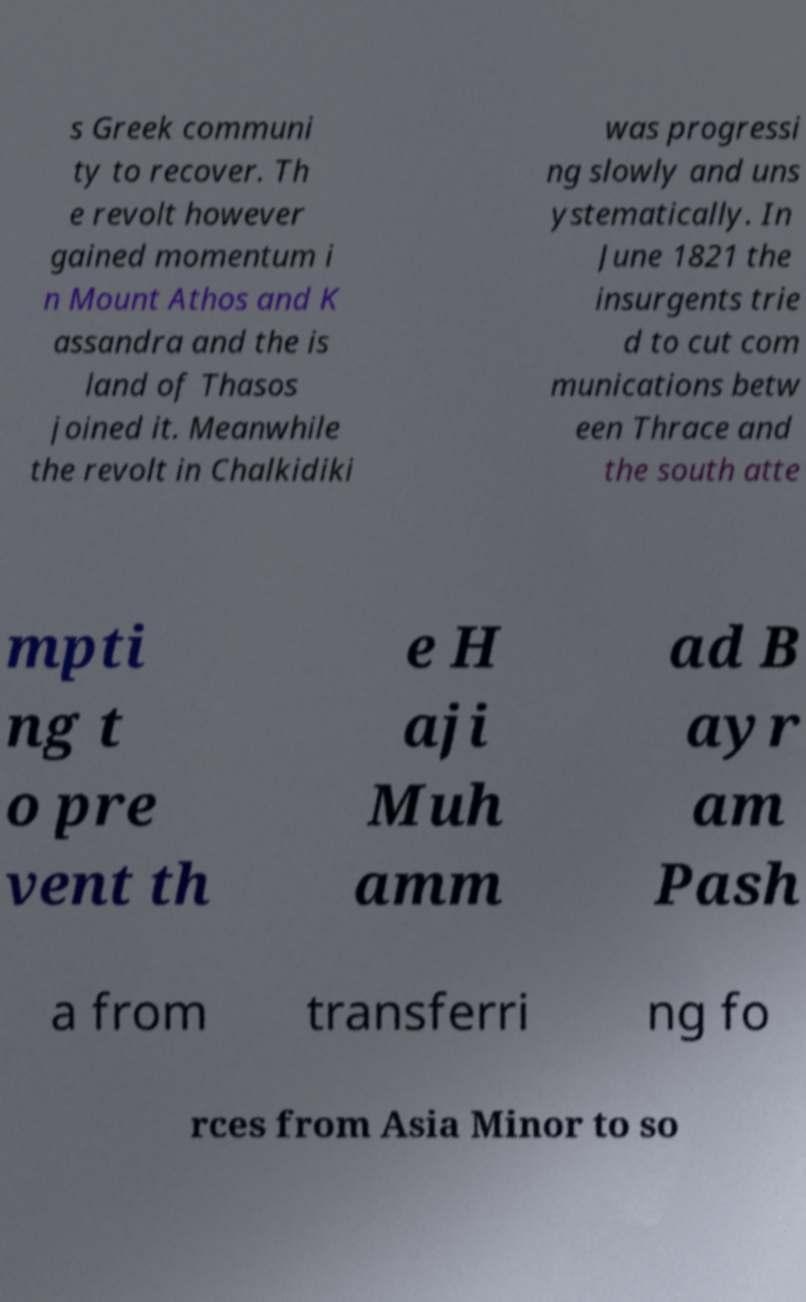Please identify and transcribe the text found in this image. s Greek communi ty to recover. Th e revolt however gained momentum i n Mount Athos and K assandra and the is land of Thasos joined it. Meanwhile the revolt in Chalkidiki was progressi ng slowly and uns ystematically. In June 1821 the insurgents trie d to cut com munications betw een Thrace and the south atte mpti ng t o pre vent th e H aji Muh amm ad B ayr am Pash a from transferri ng fo rces from Asia Minor to so 